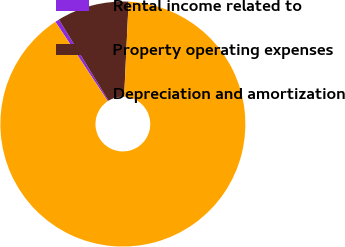Convert chart. <chart><loc_0><loc_0><loc_500><loc_500><pie_chart><fcel>Rental income related to<fcel>Property operating expenses<fcel>Depreciation and amortization<nl><fcel>0.54%<fcel>9.49%<fcel>89.97%<nl></chart> 